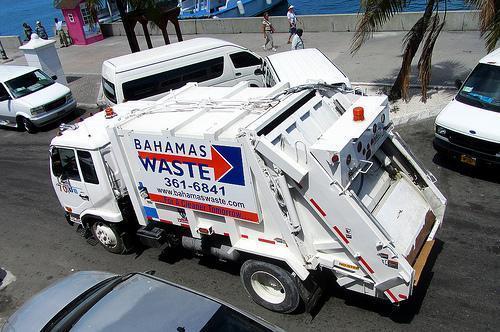How many garbage trucks are in the image?
Give a very brief answer. 1. 